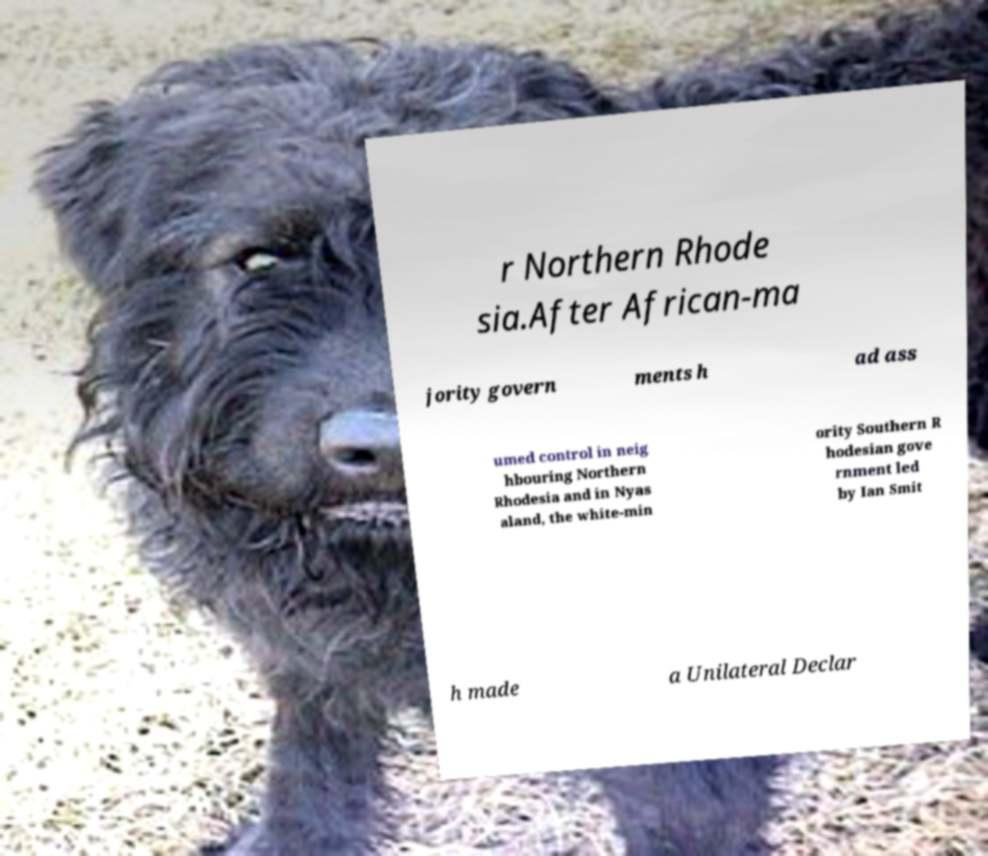Please identify and transcribe the text found in this image. r Northern Rhode sia.After African-ma jority govern ments h ad ass umed control in neig hbouring Northern Rhodesia and in Nyas aland, the white-min ority Southern R hodesian gove rnment led by Ian Smit h made a Unilateral Declar 